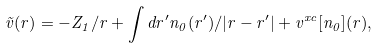Convert formula to latex. <formula><loc_0><loc_0><loc_500><loc_500>\tilde { v } ( { r } ) = - Z _ { 1 } / r + \int d { r } ^ { \prime } n _ { 0 } ( { r } ^ { \prime } ) / | { r } - { r } ^ { \prime } | + v ^ { x c } [ n _ { 0 } ] ( { r } ) ,</formula> 